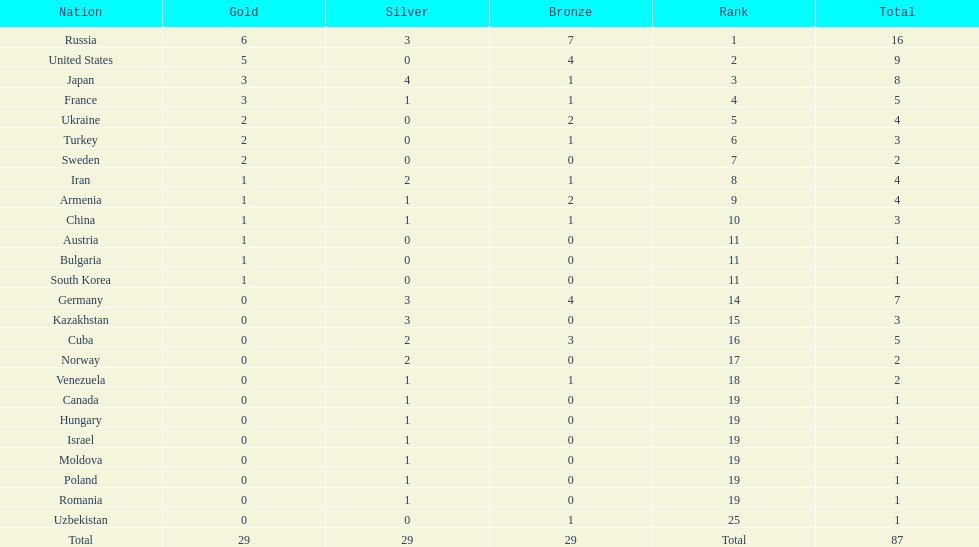Can you give me this table as a dict? {'header': ['Nation', 'Gold', 'Silver', 'Bronze', 'Rank', 'Total'], 'rows': [['Russia', '6', '3', '7', '1', '16'], ['United States', '5', '0', '4', '2', '9'], ['Japan', '3', '4', '1', '3', '8'], ['France', '3', '1', '1', '4', '5'], ['Ukraine', '2', '0', '2', '5', '4'], ['Turkey', '2', '0', '1', '6', '3'], ['Sweden', '2', '0', '0', '7', '2'], ['Iran', '1', '2', '1', '8', '4'], ['Armenia', '1', '1', '2', '9', '4'], ['China', '1', '1', '1', '10', '3'], ['Austria', '1', '0', '0', '11', '1'], ['Bulgaria', '1', '0', '0', '11', '1'], ['South Korea', '1', '0', '0', '11', '1'], ['Germany', '0', '3', '4', '14', '7'], ['Kazakhstan', '0', '3', '0', '15', '3'], ['Cuba', '0', '2', '3', '16', '5'], ['Norway', '0', '2', '0', '17', '2'], ['Venezuela', '0', '1', '1', '18', '2'], ['Canada', '0', '1', '0', '19', '1'], ['Hungary', '0', '1', '0', '19', '1'], ['Israel', '0', '1', '0', '19', '1'], ['Moldova', '0', '1', '0', '19', '1'], ['Poland', '0', '1', '0', '19', '1'], ['Romania', '0', '1', '0', '19', '1'], ['Uzbekistan', '0', '0', '1', '25', '1'], ['Total', '29', '29', '29', 'Total', '87']]} Which country won only one medal, a bronze medal? Uzbekistan. 